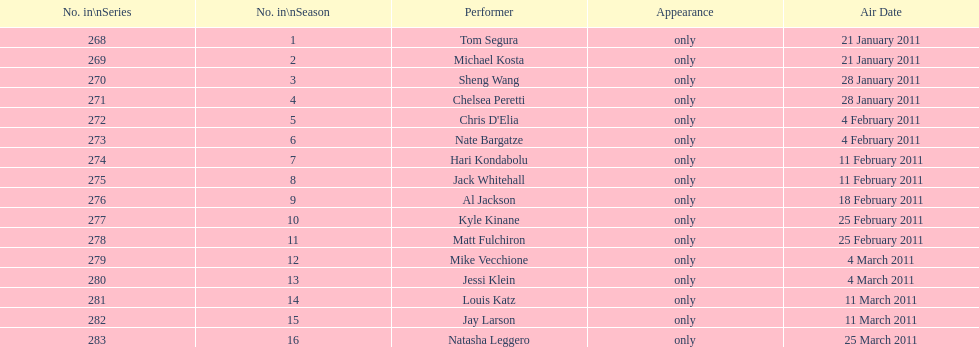Which month experienced the greatest number of air dates? February. Could you help me parse every detail presented in this table? {'header': ['No. in\\nSeries', 'No. in\\nSeason', 'Performer', 'Appearance', 'Air Date'], 'rows': [['268', '1', 'Tom Segura', 'only', '21 January 2011'], ['269', '2', 'Michael Kosta', 'only', '21 January 2011'], ['270', '3', 'Sheng Wang', 'only', '28 January 2011'], ['271', '4', 'Chelsea Peretti', 'only', '28 January 2011'], ['272', '5', "Chris D'Elia", 'only', '4 February 2011'], ['273', '6', 'Nate Bargatze', 'only', '4 February 2011'], ['274', '7', 'Hari Kondabolu', 'only', '11 February 2011'], ['275', '8', 'Jack Whitehall', 'only', '11 February 2011'], ['276', '9', 'Al Jackson', 'only', '18 February 2011'], ['277', '10', 'Kyle Kinane', 'only', '25 February 2011'], ['278', '11', 'Matt Fulchiron', 'only', '25 February 2011'], ['279', '12', 'Mike Vecchione', 'only', '4 March 2011'], ['280', '13', 'Jessi Klein', 'only', '4 March 2011'], ['281', '14', 'Louis Katz', 'only', '11 March 2011'], ['282', '15', 'Jay Larson', 'only', '11 March 2011'], ['283', '16', 'Natasha Leggero', 'only', '25 March 2011']]} 